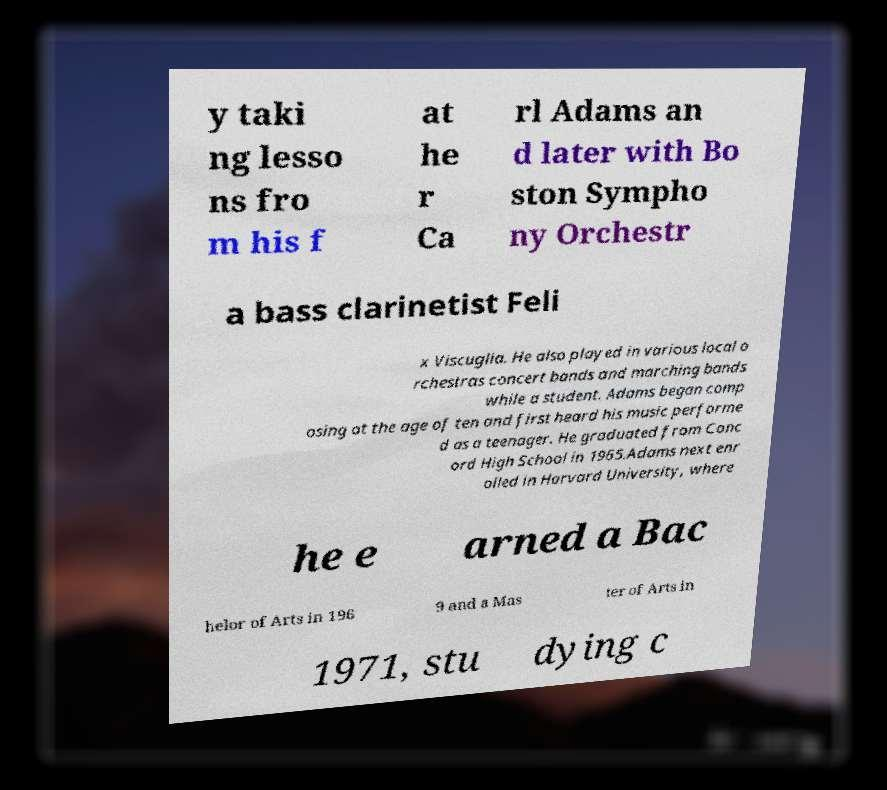Can you read and provide the text displayed in the image?This photo seems to have some interesting text. Can you extract and type it out for me? y taki ng lesso ns fro m his f at he r Ca rl Adams an d later with Bo ston Sympho ny Orchestr a bass clarinetist Feli x Viscuglia. He also played in various local o rchestras concert bands and marching bands while a student. Adams began comp osing at the age of ten and first heard his music performe d as a teenager. He graduated from Conc ord High School in 1965.Adams next enr olled in Harvard University, where he e arned a Bac helor of Arts in 196 9 and a Mas ter of Arts in 1971, stu dying c 